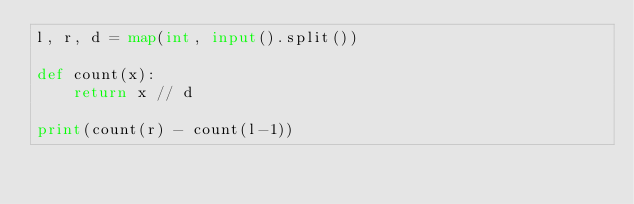<code> <loc_0><loc_0><loc_500><loc_500><_Python_>l, r, d = map(int, input().split())

def count(x):
    return x // d

print(count(r) - count(l-1))</code> 